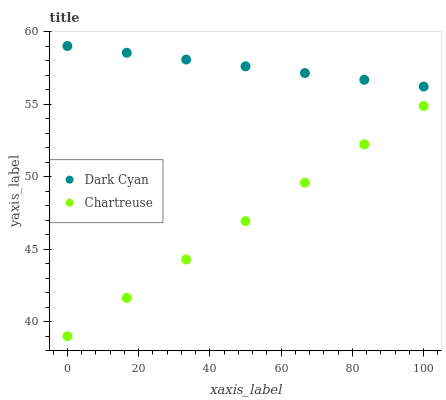Does Chartreuse have the minimum area under the curve?
Answer yes or no. Yes. Does Dark Cyan have the maximum area under the curve?
Answer yes or no. Yes. Does Chartreuse have the maximum area under the curve?
Answer yes or no. No. Is Dark Cyan the smoothest?
Answer yes or no. Yes. Is Chartreuse the roughest?
Answer yes or no. Yes. Is Chartreuse the smoothest?
Answer yes or no. No. Does Chartreuse have the lowest value?
Answer yes or no. Yes. Does Dark Cyan have the highest value?
Answer yes or no. Yes. Does Chartreuse have the highest value?
Answer yes or no. No. Is Chartreuse less than Dark Cyan?
Answer yes or no. Yes. Is Dark Cyan greater than Chartreuse?
Answer yes or no. Yes. Does Chartreuse intersect Dark Cyan?
Answer yes or no. No. 